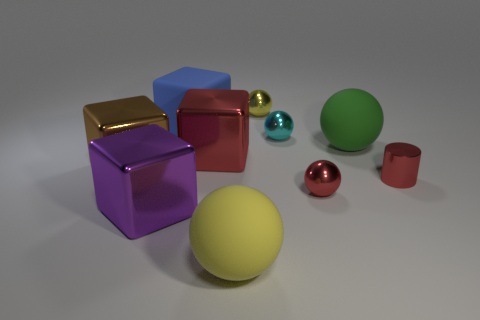How many yellow balls must be subtracted to get 1 yellow balls? 1 Subtract 1 spheres. How many spheres are left? 4 Subtract all red spheres. How many spheres are left? 4 Subtract all red balls. How many balls are left? 4 Subtract all purple balls. Subtract all green cylinders. How many balls are left? 5 Subtract all blocks. How many objects are left? 6 Subtract all cyan things. Subtract all big things. How many objects are left? 3 Add 8 brown metal blocks. How many brown metal blocks are left? 9 Add 7 small red metallic cylinders. How many small red metallic cylinders exist? 8 Subtract 0 purple balls. How many objects are left? 10 